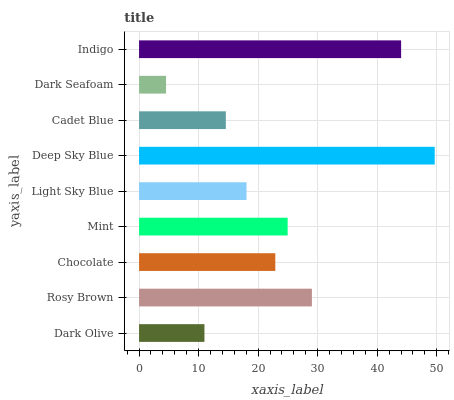Is Dark Seafoam the minimum?
Answer yes or no. Yes. Is Deep Sky Blue the maximum?
Answer yes or no. Yes. Is Rosy Brown the minimum?
Answer yes or no. No. Is Rosy Brown the maximum?
Answer yes or no. No. Is Rosy Brown greater than Dark Olive?
Answer yes or no. Yes. Is Dark Olive less than Rosy Brown?
Answer yes or no. Yes. Is Dark Olive greater than Rosy Brown?
Answer yes or no. No. Is Rosy Brown less than Dark Olive?
Answer yes or no. No. Is Chocolate the high median?
Answer yes or no. Yes. Is Chocolate the low median?
Answer yes or no. Yes. Is Cadet Blue the high median?
Answer yes or no. No. Is Dark Seafoam the low median?
Answer yes or no. No. 